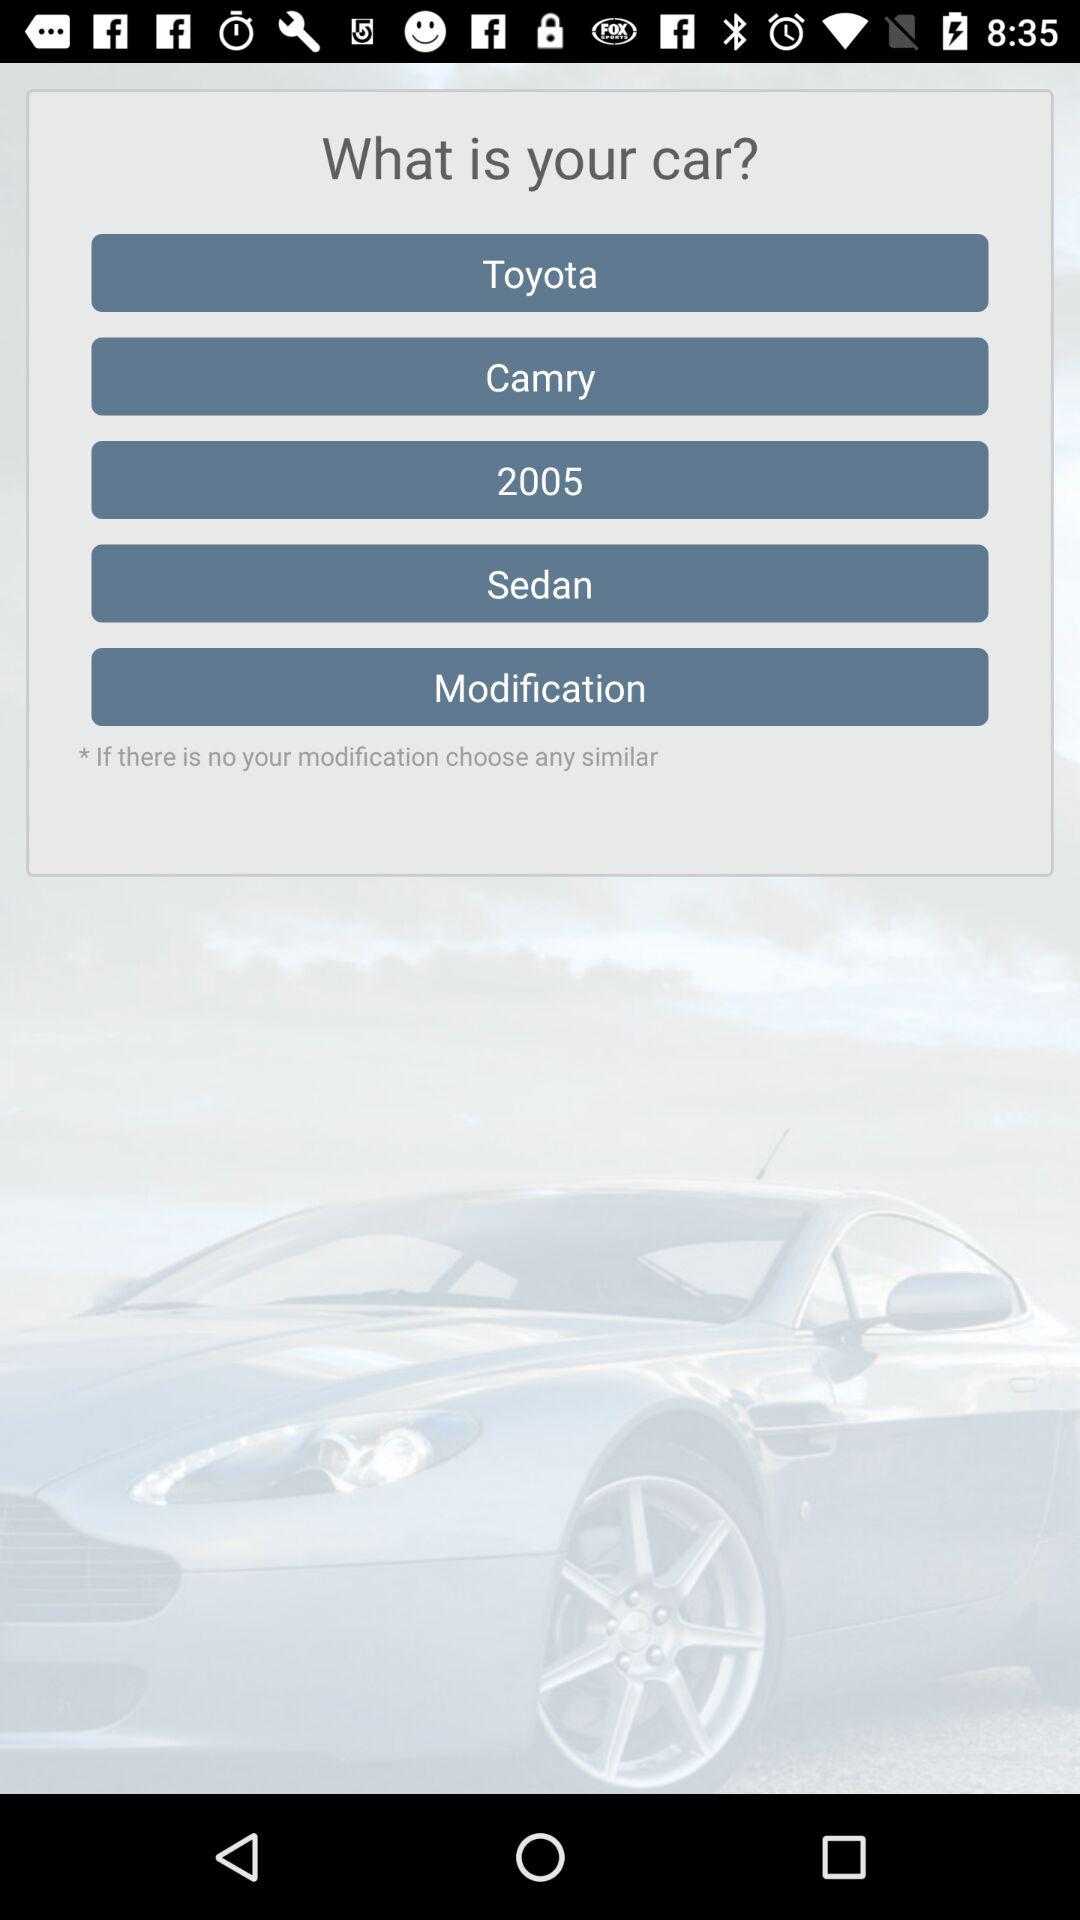What is the type of car? The type of the car is "Sedan". 